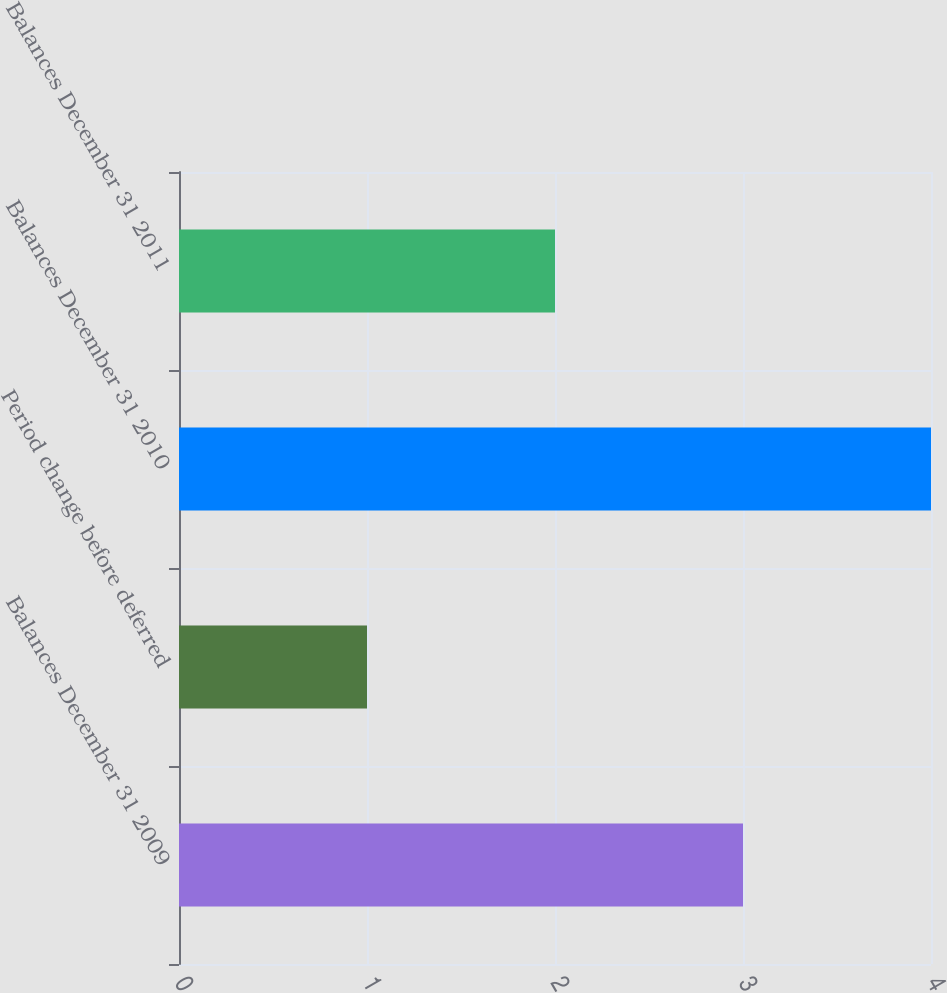<chart> <loc_0><loc_0><loc_500><loc_500><bar_chart><fcel>Balances December 31 2009<fcel>Period change before deferred<fcel>Balances December 31 2010<fcel>Balances December 31 2011<nl><fcel>3<fcel>1<fcel>4<fcel>2<nl></chart> 